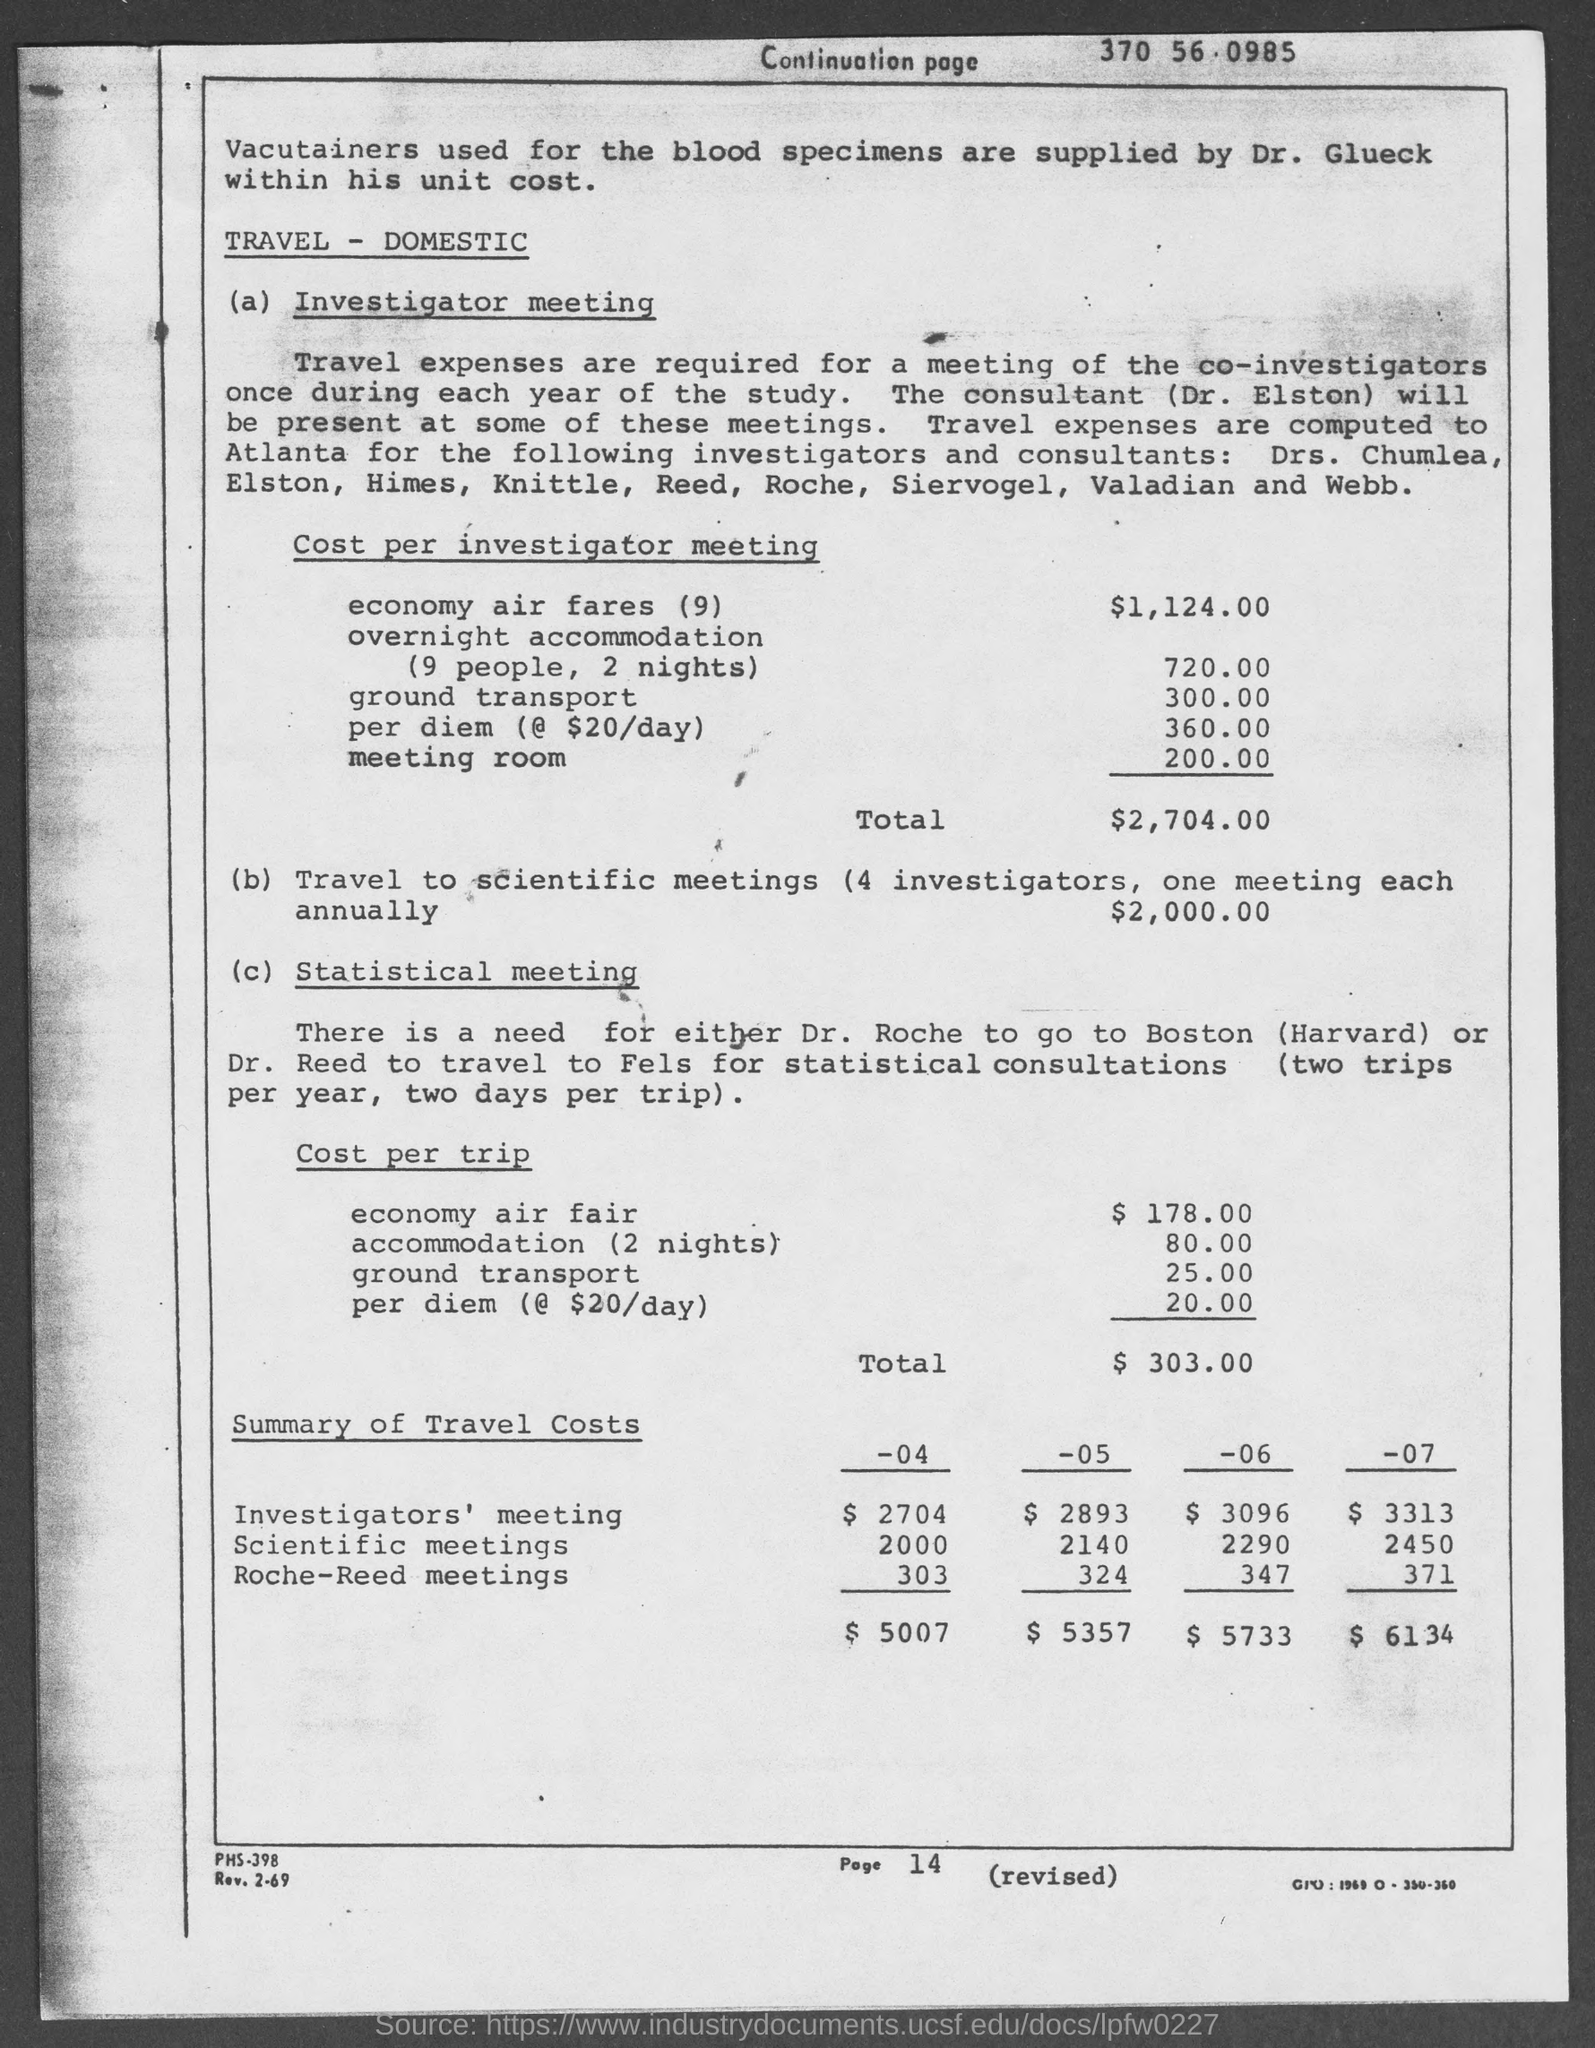Identify some key points in this picture. It has been decided that Dr. Elston will be present at some of the meetings. It is known that Dr. Glueck is supplying vacutainers. 